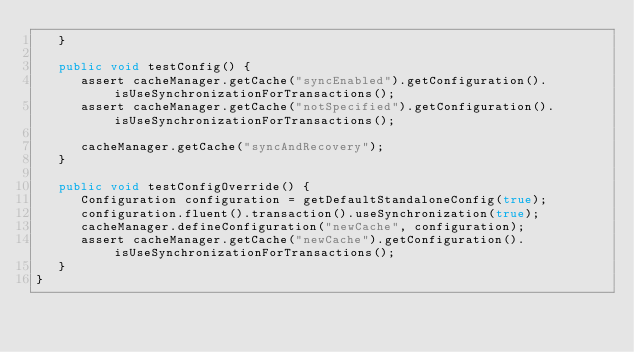Convert code to text. <code><loc_0><loc_0><loc_500><loc_500><_Java_>   }

   public void testConfig() {
      assert cacheManager.getCache("syncEnabled").getConfiguration().isUseSynchronizationForTransactions();
      assert cacheManager.getCache("notSpecified").getConfiguration().isUseSynchronizationForTransactions();

      cacheManager.getCache("syncAndRecovery");
   }

   public void testConfigOverride() {
      Configuration configuration = getDefaultStandaloneConfig(true);
      configuration.fluent().transaction().useSynchronization(true);
      cacheManager.defineConfiguration("newCache", configuration);
      assert cacheManager.getCache("newCache").getConfiguration().isUseSynchronizationForTransactions();
   }
}
</code> 